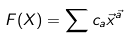Convert formula to latex. <formula><loc_0><loc_0><loc_500><loc_500>F ( X ) = \sum c _ { a } \vec { x } ^ { \vec { a } } \\</formula> 